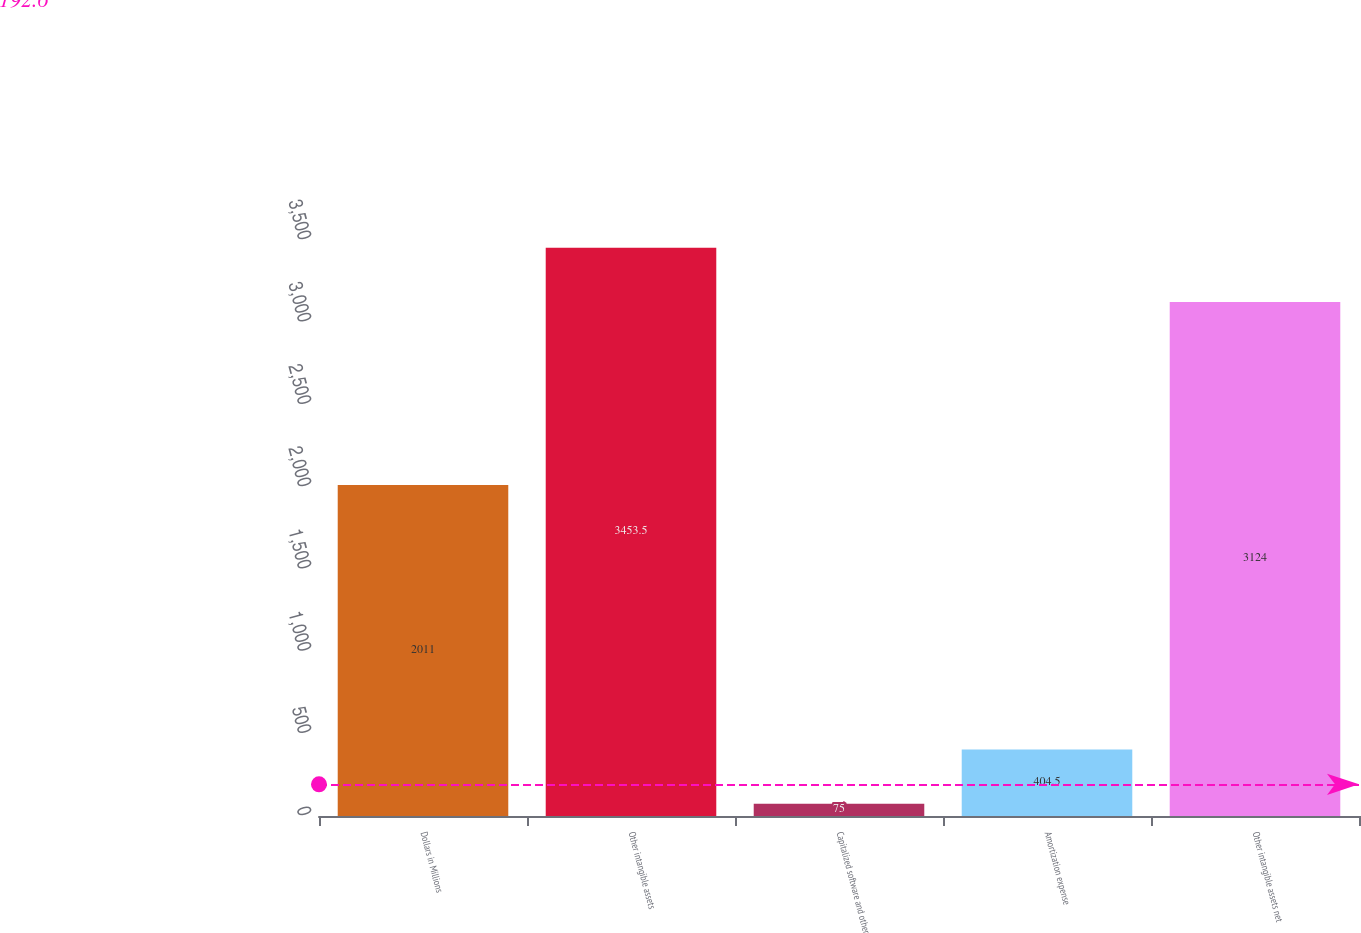<chart> <loc_0><loc_0><loc_500><loc_500><bar_chart><fcel>Dollars in Millions<fcel>Other intangible assets<fcel>Capitalized software and other<fcel>Amortization expense<fcel>Other intangible assets net<nl><fcel>2011<fcel>3453.5<fcel>75<fcel>404.5<fcel>3124<nl></chart> 